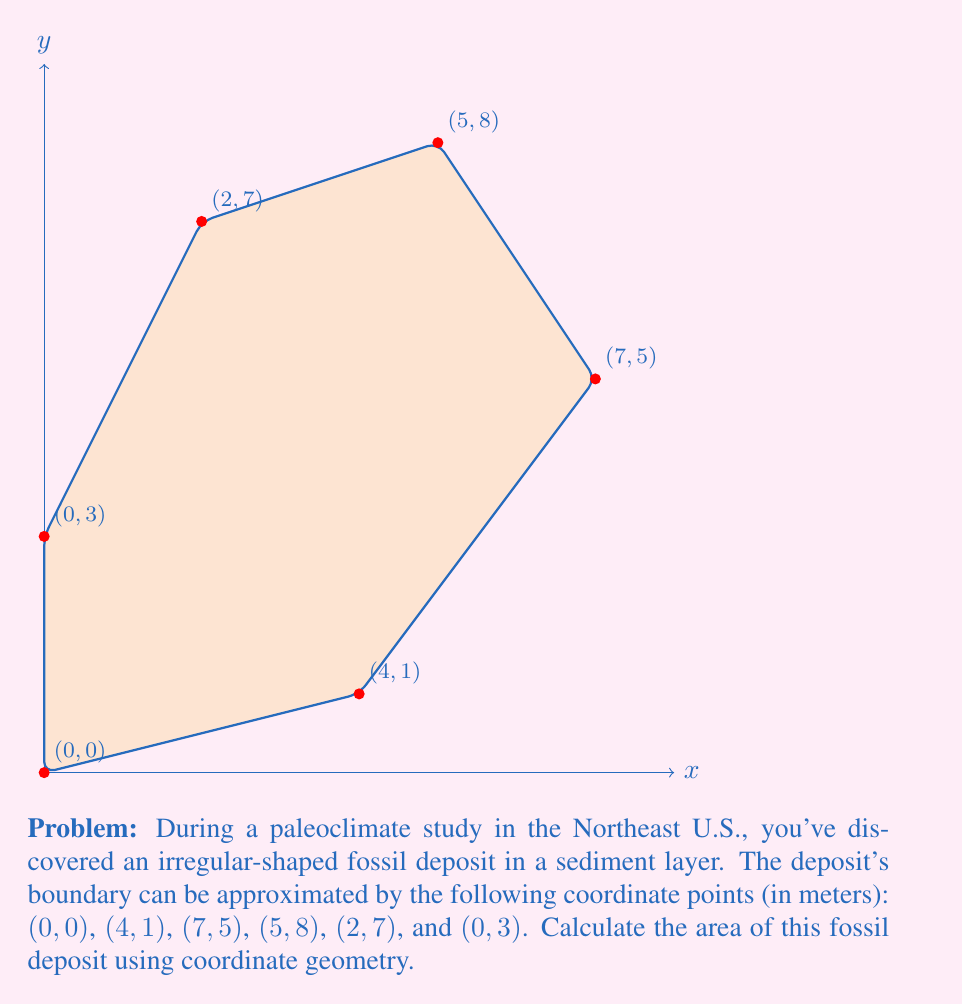Provide a solution to this math problem. To find the area of this irregular polygon, we can use the Shoelace formula (also known as the surveyor's formula). The formula is:

$$ A = \frac{1}{2}|\sum_{i=1}^{n-1} (x_i y_{i+1} - x_{i+1} y_i) + (x_n y_1 - x_1 y_n)| $$

Where $(x_i, y_i)$ are the coordinates of the $i$-th vertex.

Let's apply this formula to our coordinates:

1) First, let's organize our data:
   $(x_1, y_1) = (0, 0)$
   $(x_2, y_2) = (4, 1)$
   $(x_3, y_3) = (7, 5)$
   $(x_4, y_4) = (5, 8)$
   $(x_5, y_5) = (2, 7)$
   $(x_6, y_6) = (0, 3)$

2) Now, let's calculate each term in the sum:
   $(0 \cdot 1 - 4 \cdot 0) = 0$
   $(4 \cdot 5 - 7 \cdot 1) = 13$
   $(7 \cdot 8 - 5 \cdot 5) = 31$
   $(5 \cdot 7 - 2 \cdot 8) = 19$
   $(2 \cdot 3 - 0 \cdot 7) = 6$
   $(0 \cdot 0 - 0 \cdot 3) = 0$

3) Sum these values:
   $0 + 13 + 31 + 19 + 6 + 0 = 69$

4) Multiply by $\frac{1}{2}$:
   $\frac{1}{2} \cdot 69 = 34.5$

Therefore, the area of the fossil deposit is 34.5 square meters.
Answer: $34.5 \text{ m}^2$ 